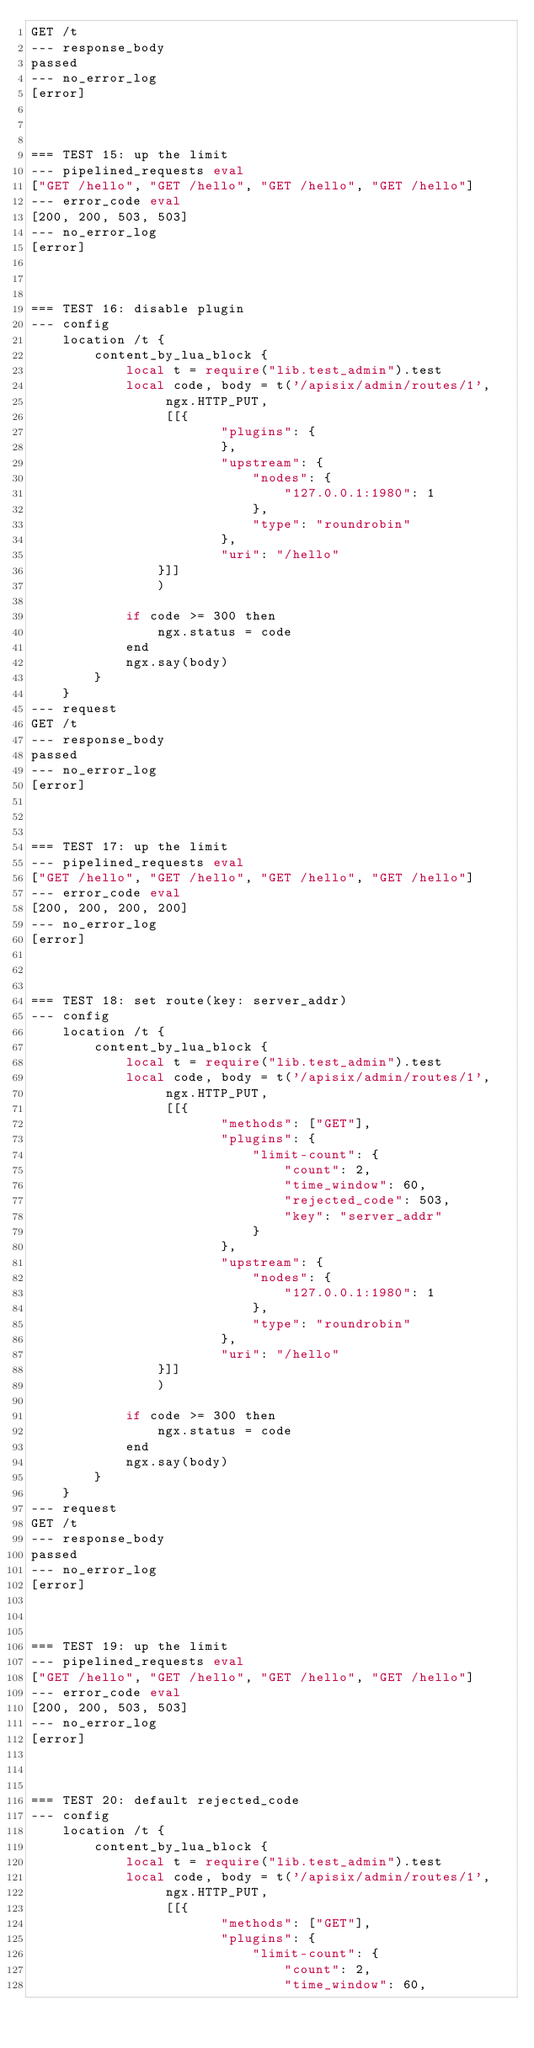Convert code to text. <code><loc_0><loc_0><loc_500><loc_500><_Perl_>GET /t
--- response_body
passed
--- no_error_log
[error]



=== TEST 15: up the limit
--- pipelined_requests eval
["GET /hello", "GET /hello", "GET /hello", "GET /hello"]
--- error_code eval
[200, 200, 503, 503]
--- no_error_log
[error]



=== TEST 16: disable plugin
--- config
    location /t {
        content_by_lua_block {
            local t = require("lib.test_admin").test
            local code, body = t('/apisix/admin/routes/1',
                 ngx.HTTP_PUT,
                 [[{
                        "plugins": {
                        },
                        "upstream": {
                            "nodes": {
                                "127.0.0.1:1980": 1
                            },
                            "type": "roundrobin"
                        },
                        "uri": "/hello"
                }]]
                )

            if code >= 300 then
                ngx.status = code
            end
            ngx.say(body)
        }
    }
--- request
GET /t
--- response_body
passed
--- no_error_log
[error]



=== TEST 17: up the limit
--- pipelined_requests eval
["GET /hello", "GET /hello", "GET /hello", "GET /hello"]
--- error_code eval
[200, 200, 200, 200]
--- no_error_log
[error]



=== TEST 18: set route(key: server_addr)
--- config
    location /t {
        content_by_lua_block {
            local t = require("lib.test_admin").test
            local code, body = t('/apisix/admin/routes/1',
                 ngx.HTTP_PUT,
                 [[{
                        "methods": ["GET"],
                        "plugins": {
                            "limit-count": {
                                "count": 2,
                                "time_window": 60,
                                "rejected_code": 503,
                                "key": "server_addr"
                            }
                        },
                        "upstream": {
                            "nodes": {
                                "127.0.0.1:1980": 1
                            },
                            "type": "roundrobin"
                        },
                        "uri": "/hello"
                }]]
                )

            if code >= 300 then
                ngx.status = code
            end
            ngx.say(body)
        }
    }
--- request
GET /t
--- response_body
passed
--- no_error_log
[error]



=== TEST 19: up the limit
--- pipelined_requests eval
["GET /hello", "GET /hello", "GET /hello", "GET /hello"]
--- error_code eval
[200, 200, 503, 503]
--- no_error_log
[error]



=== TEST 20: default rejected_code
--- config
    location /t {
        content_by_lua_block {
            local t = require("lib.test_admin").test
            local code, body = t('/apisix/admin/routes/1',
                 ngx.HTTP_PUT,
                 [[{
                        "methods": ["GET"],
                        "plugins": {
                            "limit-count": {
                                "count": 2,
                                "time_window": 60,</code> 